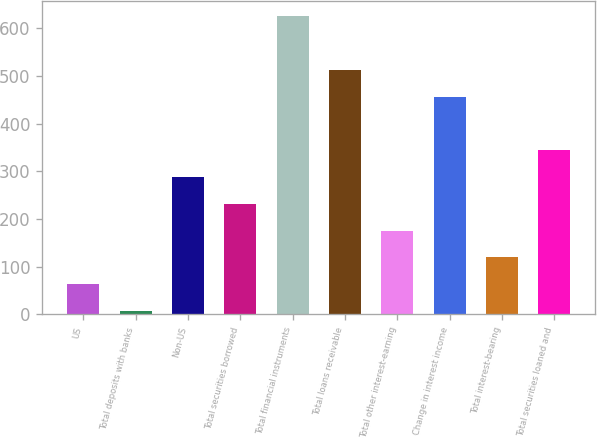Convert chart. <chart><loc_0><loc_0><loc_500><loc_500><bar_chart><fcel>US<fcel>Total deposits with banks<fcel>Non-US<fcel>Total securities borrowed<fcel>Total financial instruments<fcel>Total loans receivable<fcel>Total other interest-earning<fcel>Change in interest income<fcel>Total interest-bearing<fcel>Total securities loaned and<nl><fcel>63.2<fcel>7<fcel>288<fcel>231.8<fcel>625.2<fcel>512.8<fcel>175.6<fcel>456.6<fcel>119.4<fcel>344.2<nl></chart> 